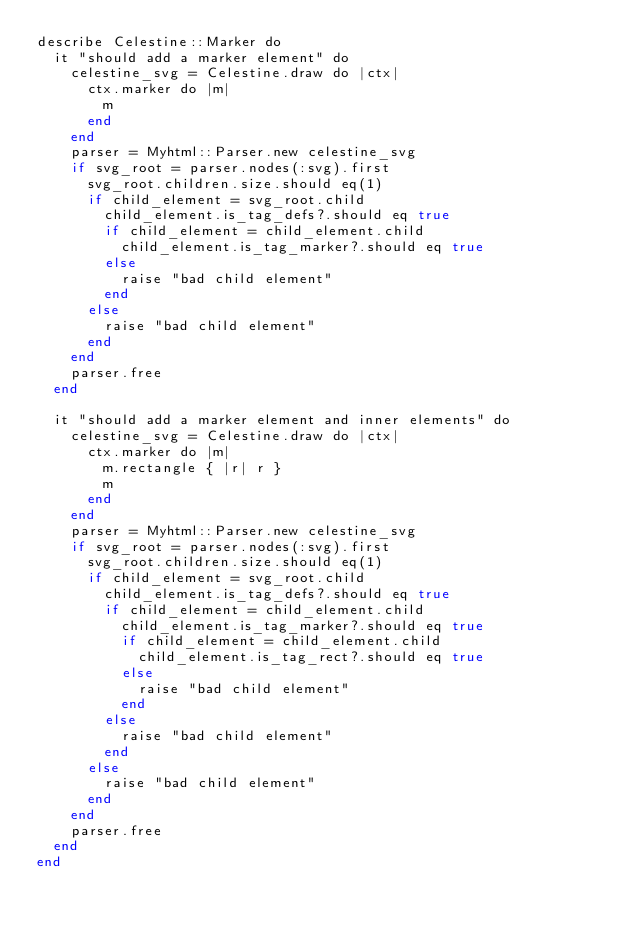Convert code to text. <code><loc_0><loc_0><loc_500><loc_500><_Crystal_>describe Celestine::Marker do
  it "should add a marker element" do
    celestine_svg = Celestine.draw do |ctx|
      ctx.marker do |m|
        m
      end
    end
    parser = Myhtml::Parser.new celestine_svg
    if svg_root = parser.nodes(:svg).first
      svg_root.children.size.should eq(1)
      if child_element = svg_root.child
        child_element.is_tag_defs?.should eq true
        if child_element = child_element.child
          child_element.is_tag_marker?.should eq true
        else
          raise "bad child element"
        end
      else
        raise "bad child element"
      end
    end
    parser.free
  end

  it "should add a marker element and inner elements" do
    celestine_svg = Celestine.draw do |ctx|
      ctx.marker do |m|
        m.rectangle { |r| r }
        m
      end
    end
    parser = Myhtml::Parser.new celestine_svg
    if svg_root = parser.nodes(:svg).first
      svg_root.children.size.should eq(1)
      if child_element = svg_root.child
        child_element.is_tag_defs?.should eq true
        if child_element = child_element.child
          child_element.is_tag_marker?.should eq true
          if child_element = child_element.child
            child_element.is_tag_rect?.should eq true
          else
            raise "bad child element"
          end
        else
          raise "bad child element"
        end
      else
        raise "bad child element"
      end
    end
    parser.free
  end
end
</code> 